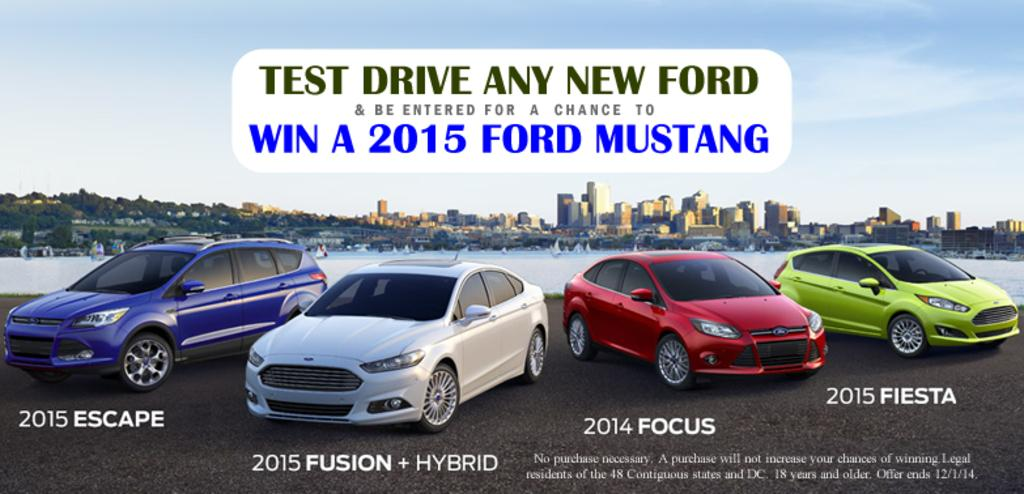What is featured on the poster in the image? There is a poster in the image, and there is writing on the poster. What else can be seen in the image besides the poster? Cars are visible in the image, as well as buildings and water in the background. What is the condition of the sky in the image? The sky is visible in the background of the image. What type of rake is being used to care for the plants in the image? There are no plants or rakes present in the image. How many gloves can be seen on the person in the image? There is no person or gloves present in the image. 